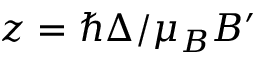<formula> <loc_0><loc_0><loc_500><loc_500>z = \hbar { \Delta } / \mu _ { B } B ^ { \prime }</formula> 